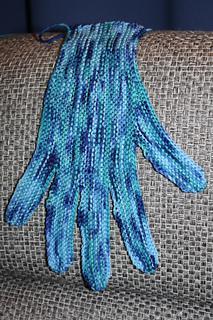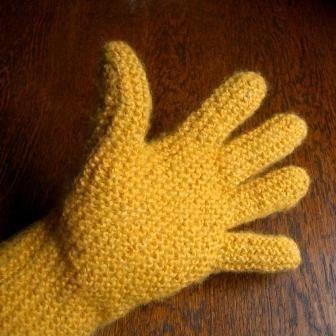The first image is the image on the left, the second image is the image on the right. For the images displayed, is the sentence "The left and right image contains a total of three gloves." factually correct? Answer yes or no. No. The first image is the image on the left, the second image is the image on the right. Evaluate the accuracy of this statement regarding the images: "One image shows a completed pair of 'mittens', and the other image shows a single completed item worn on the hand.". Is it true? Answer yes or no. No. 